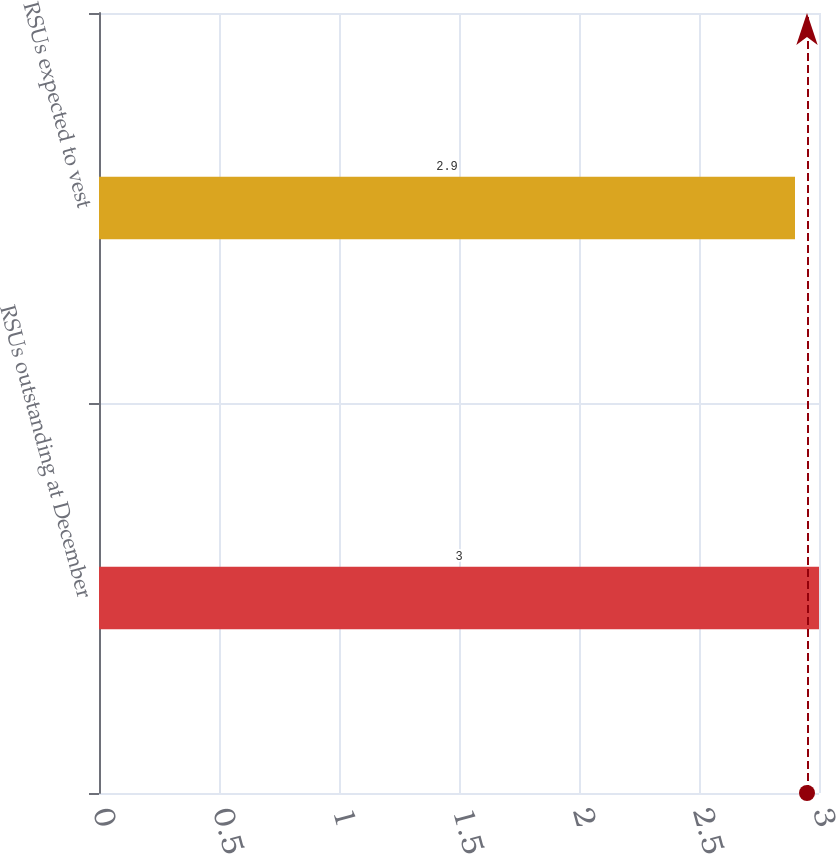Convert chart to OTSL. <chart><loc_0><loc_0><loc_500><loc_500><bar_chart><fcel>RSUs outstanding at December<fcel>RSUs expected to vest<nl><fcel>3<fcel>2.9<nl></chart> 